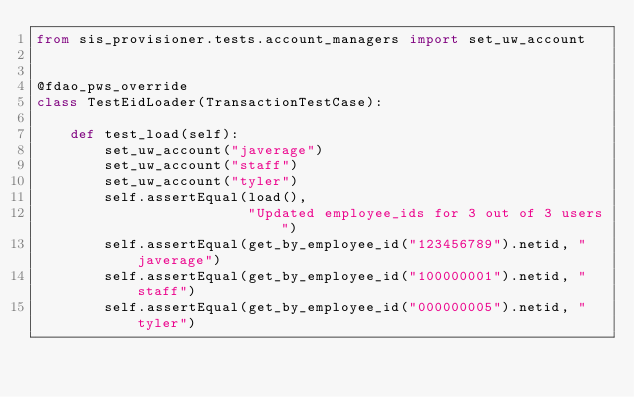<code> <loc_0><loc_0><loc_500><loc_500><_Python_>from sis_provisioner.tests.account_managers import set_uw_account


@fdao_pws_override
class TestEidLoader(TransactionTestCase):

    def test_load(self):
        set_uw_account("javerage")
        set_uw_account("staff")
        set_uw_account("tyler")
        self.assertEqual(load(),
                         "Updated employee_ids for 3 out of 3 users")
        self.assertEqual(get_by_employee_id("123456789").netid, "javerage")
        self.assertEqual(get_by_employee_id("100000001").netid, "staff")
        self.assertEqual(get_by_employee_id("000000005").netid, "tyler")
</code> 